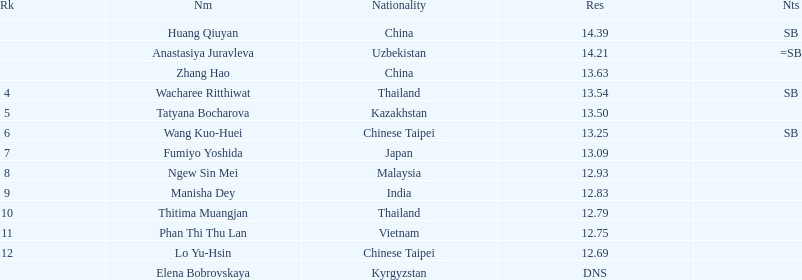How many points apart were the 1st place competitor and the 12th place competitor? 1.7. 